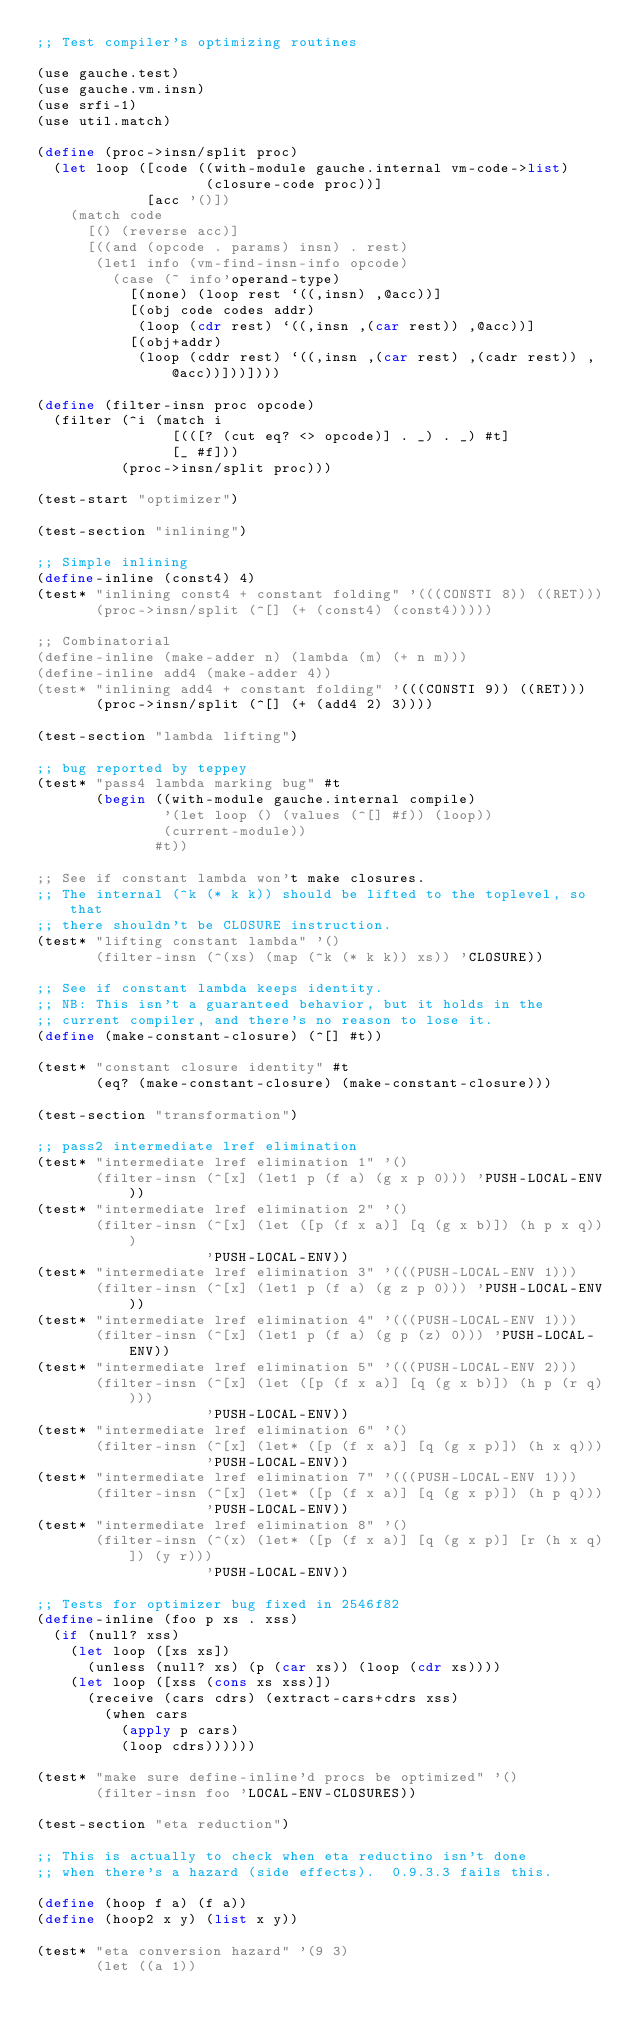<code> <loc_0><loc_0><loc_500><loc_500><_Scheme_>;; Test compiler's optimizing routines

(use gauche.test)
(use gauche.vm.insn)
(use srfi-1)
(use util.match)

(define (proc->insn/split proc)
  (let loop ([code ((with-module gauche.internal vm-code->list)
                    (closure-code proc))]
             [acc '()])
    (match code
      [() (reverse acc)]
      [((and (opcode . params) insn) . rest)
       (let1 info (vm-find-insn-info opcode)
         (case (~ info'operand-type)
           [(none) (loop rest `((,insn) ,@acc))]
           [(obj code codes addr)
            (loop (cdr rest) `((,insn ,(car rest)) ,@acc))]
           [(obj+addr)
            (loop (cddr rest) `((,insn ,(car rest) ,(cadr rest)) ,@acc))]))])))

(define (filter-insn proc opcode)
  (filter (^i (match i
                [(([? (cut eq? <> opcode)] . _) . _) #t]
                [_ #f]))
          (proc->insn/split proc)))

(test-start "optimizer")

(test-section "inlining")

;; Simple inlining
(define-inline (const4) 4)
(test* "inlining const4 + constant folding" '(((CONSTI 8)) ((RET)))
       (proc->insn/split (^[] (+ (const4) (const4)))))

;; Combinatorial
(define-inline (make-adder n) (lambda (m) (+ n m)))
(define-inline add4 (make-adder 4))
(test* "inlining add4 + constant folding" '(((CONSTI 9)) ((RET)))
       (proc->insn/split (^[] (+ (add4 2) 3))))

(test-section "lambda lifting")

;; bug reported by teppey
(test* "pass4 lambda marking bug" #t
       (begin ((with-module gauche.internal compile)
               '(let loop () (values (^[] #f)) (loop))
               (current-module))
              #t))

;; See if constant lambda won't make closures.
;; The internal (^k (* k k)) should be lifted to the toplevel, so that
;; there shouldn't be CLOSURE instruction.
(test* "lifting constant lambda" '()
       (filter-insn (^(xs) (map (^k (* k k)) xs)) 'CLOSURE))

;; See if constant lambda keeps identity.
;; NB: This isn't a guaranteed behavior, but it holds in the
;; current compiler, and there's no reason to lose it.
(define (make-constant-closure) (^[] #t))

(test* "constant closure identity" #t
       (eq? (make-constant-closure) (make-constant-closure)))

(test-section "transformation")

;; pass2 intermediate lref elimination
(test* "intermediate lref elimination 1" '()
       (filter-insn (^[x] (let1 p (f a) (g x p 0))) 'PUSH-LOCAL-ENV))
(test* "intermediate lref elimination 2" '()
       (filter-insn (^[x] (let ([p (f x a)] [q (g x b)]) (h p x q)))
                    'PUSH-LOCAL-ENV))
(test* "intermediate lref elimination 3" '(((PUSH-LOCAL-ENV 1)))
       (filter-insn (^[x] (let1 p (f a) (g z p 0))) 'PUSH-LOCAL-ENV))
(test* "intermediate lref elimination 4" '(((PUSH-LOCAL-ENV 1)))
       (filter-insn (^[x] (let1 p (f a) (g p (z) 0))) 'PUSH-LOCAL-ENV))
(test* "intermediate lref elimination 5" '(((PUSH-LOCAL-ENV 2)))
       (filter-insn (^[x] (let ([p (f x a)] [q (g x b)]) (h p (r q))))
                    'PUSH-LOCAL-ENV))
(test* "intermediate lref elimination 6" '()
       (filter-insn (^[x] (let* ([p (f x a)] [q (g x p)]) (h x q)))
                    'PUSH-LOCAL-ENV))
(test* "intermediate lref elimination 7" '(((PUSH-LOCAL-ENV 1)))
       (filter-insn (^[x] (let* ([p (f x a)] [q (g x p)]) (h p q)))
                    'PUSH-LOCAL-ENV))
(test* "intermediate lref elimination 8" '()
       (filter-insn (^(x) (let* ([p (f x a)] [q (g x p)] [r (h x q)]) (y r)))
                    'PUSH-LOCAL-ENV))

;; Tests for optimizer bug fixed in 2546f82
(define-inline (foo p xs . xss)
  (if (null? xss)
    (let loop ([xs xs])
      (unless (null? xs) (p (car xs)) (loop (cdr xs))))
    (let loop ([xss (cons xs xss)])
      (receive (cars cdrs) (extract-cars+cdrs xss)
        (when cars
          (apply p cars)
          (loop cdrs))))))

(test* "make sure define-inline'd procs be optimized" '()
       (filter-insn foo 'LOCAL-ENV-CLOSURES))

(test-section "eta reduction")

;; This is actually to check when eta reductino isn't done
;; when there's a hazard (side effects).  0.9.3.3 fails this.

(define (hoop f a) (f a))
(define (hoop2 x y) (list x y))

(test* "eta conversion hazard" '(9 3)
       (let ((a 1))</code> 